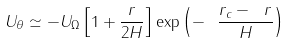Convert formula to latex. <formula><loc_0><loc_0><loc_500><loc_500>U _ { \theta } \simeq - U _ { \Omega } \left [ 1 + \frac { r } { 2 H } \right ] \exp \left ( - \ \frac { r _ { c } - \ r } { H } \right )</formula> 